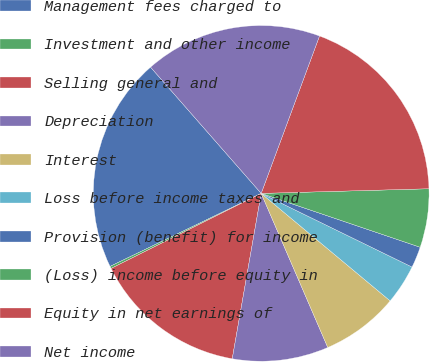Convert chart. <chart><loc_0><loc_0><loc_500><loc_500><pie_chart><fcel>Management fees charged to<fcel>Investment and other income<fcel>Selling general and<fcel>Depreciation<fcel>Interest<fcel>Loss before income taxes and<fcel>Provision (benefit) for income<fcel>(Loss) income before equity in<fcel>Equity in net earnings of<fcel>Net income<nl><fcel>20.71%<fcel>0.22%<fcel>14.86%<fcel>9.25%<fcel>7.45%<fcel>3.83%<fcel>2.03%<fcel>5.64%<fcel>18.91%<fcel>17.1%<nl></chart> 